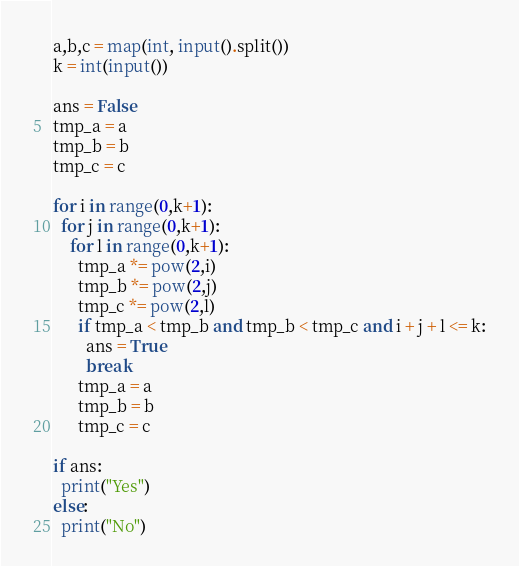Convert code to text. <code><loc_0><loc_0><loc_500><loc_500><_Python_>a,b,c = map(int, input().split())
k = int(input())

ans = False
tmp_a = a
tmp_b = b
tmp_c = c

for i in range(0,k+1):
  for j in range(0,k+1):
    for l in range(0,k+1):
      tmp_a *= pow(2,i)
      tmp_b *= pow(2,j)
      tmp_c *= pow(2,l)
      if tmp_a < tmp_b and tmp_b < tmp_c and i + j + l <= k:
        ans = True
        break
      tmp_a = a
      tmp_b = b
      tmp_c = c

if ans:
  print("Yes")
else:
  print("No")</code> 